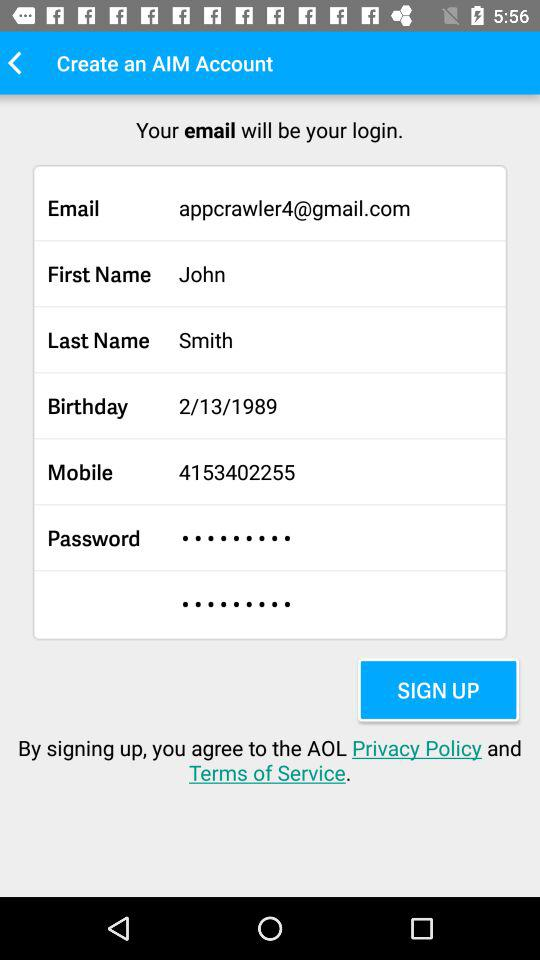What is John's birthday date? The birthday date is February 13, 1989. 